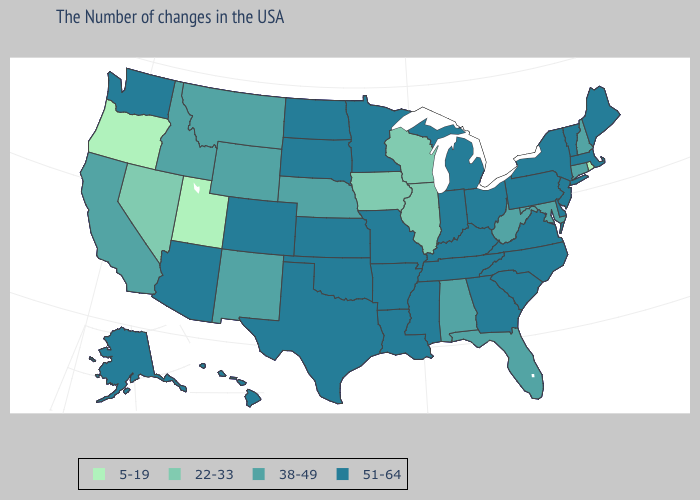What is the value of Illinois?
Concise answer only. 22-33. Name the states that have a value in the range 51-64?
Keep it brief. Maine, Massachusetts, Vermont, New York, New Jersey, Delaware, Pennsylvania, Virginia, North Carolina, South Carolina, Ohio, Georgia, Michigan, Kentucky, Indiana, Tennessee, Mississippi, Louisiana, Missouri, Arkansas, Minnesota, Kansas, Oklahoma, Texas, South Dakota, North Dakota, Colorado, Arizona, Washington, Alaska, Hawaii. Among the states that border California , does Arizona have the highest value?
Quick response, please. Yes. What is the highest value in the Northeast ?
Keep it brief. 51-64. Does the map have missing data?
Write a very short answer. No. Does Montana have the highest value in the USA?
Write a very short answer. No. Does Florida have the same value as Georgia?
Answer briefly. No. What is the highest value in the MidWest ?
Concise answer only. 51-64. What is the value of Wyoming?
Be succinct. 38-49. Name the states that have a value in the range 51-64?
Concise answer only. Maine, Massachusetts, Vermont, New York, New Jersey, Delaware, Pennsylvania, Virginia, North Carolina, South Carolina, Ohio, Georgia, Michigan, Kentucky, Indiana, Tennessee, Mississippi, Louisiana, Missouri, Arkansas, Minnesota, Kansas, Oklahoma, Texas, South Dakota, North Dakota, Colorado, Arizona, Washington, Alaska, Hawaii. Does Oregon have a lower value than Rhode Island?
Give a very brief answer. No. Does the map have missing data?
Be succinct. No. What is the lowest value in the South?
Write a very short answer. 38-49. Does Idaho have the highest value in the USA?
Keep it brief. No. What is the value of Delaware?
Answer briefly. 51-64. 